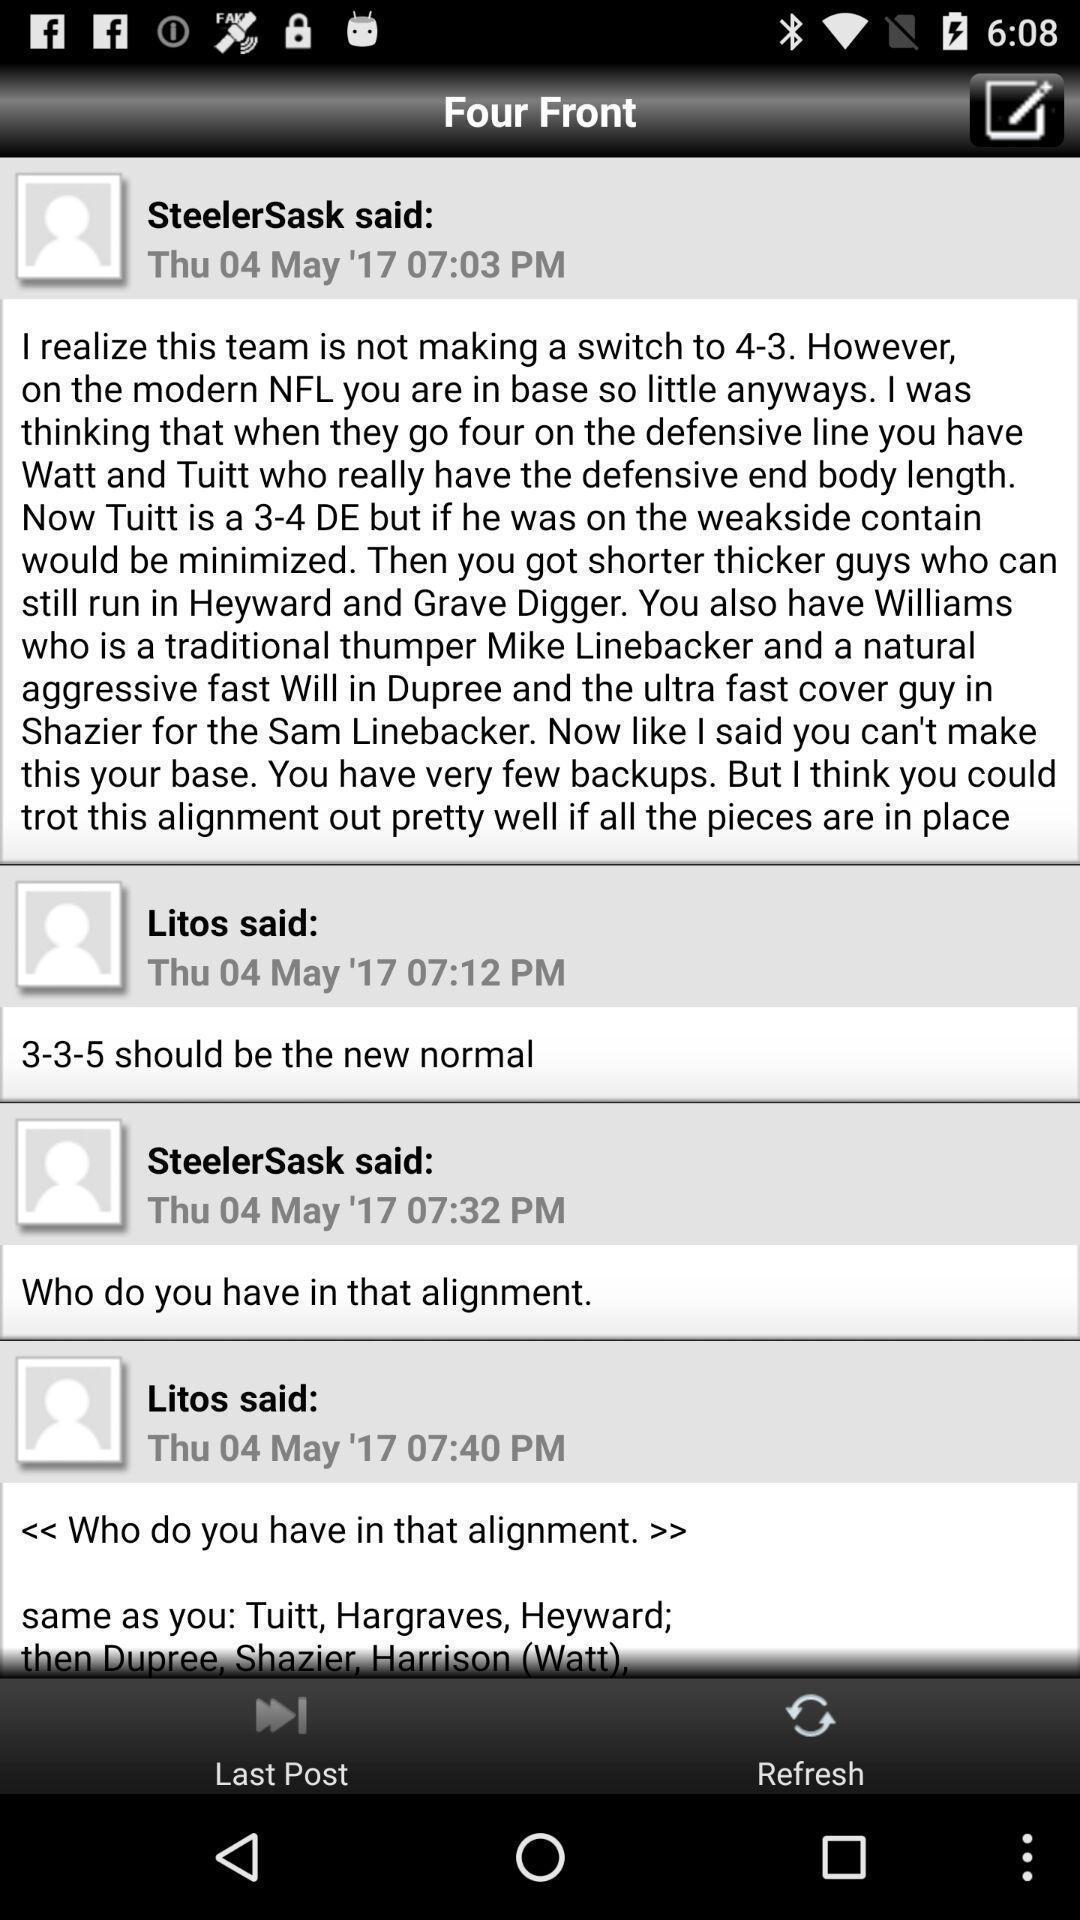Provide a description of this screenshot. Page showing content related to a forums app. 